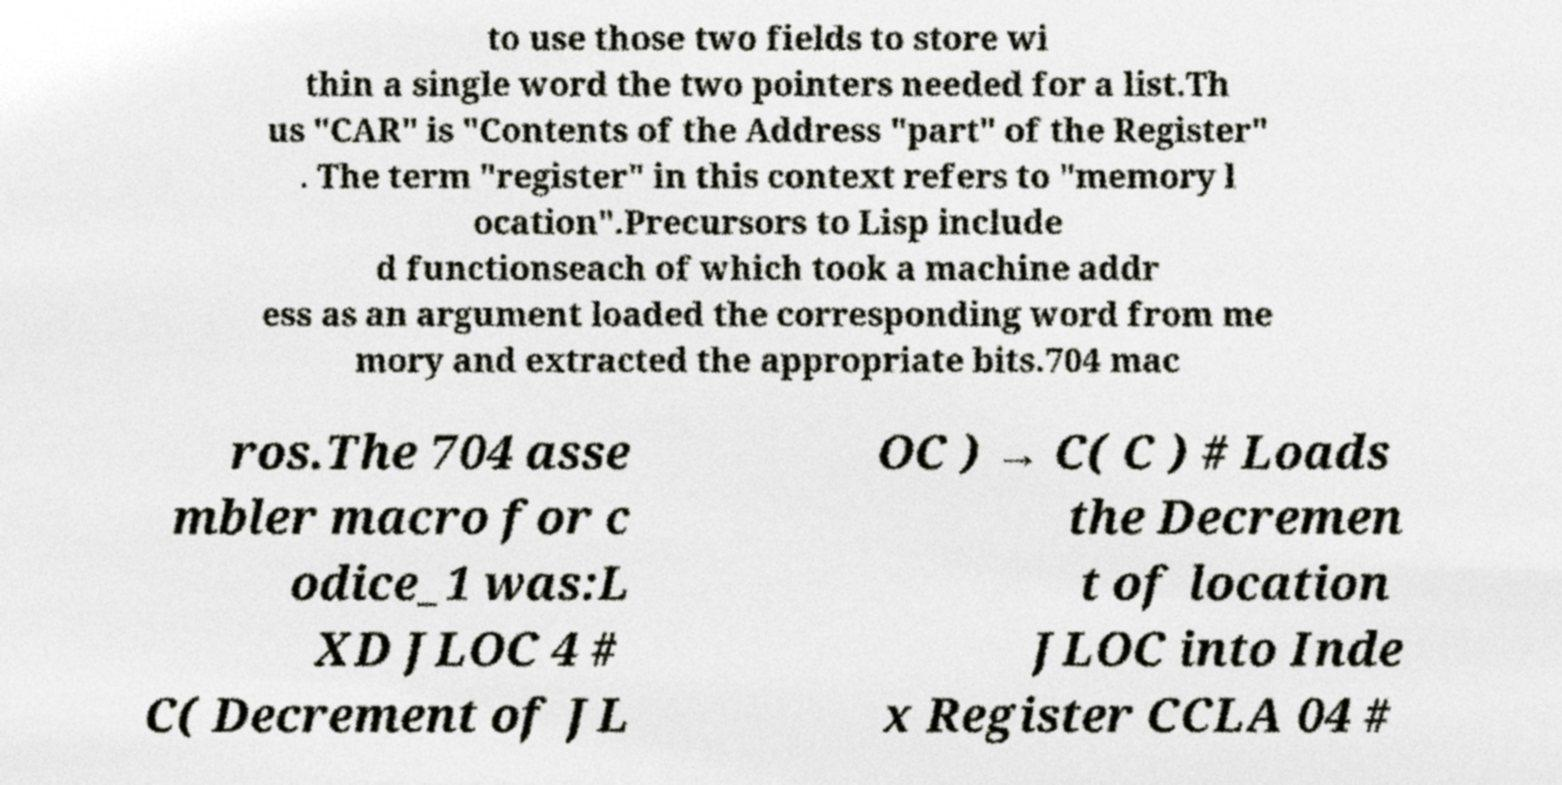What messages or text are displayed in this image? I need them in a readable, typed format. to use those two fields to store wi thin a single word the two pointers needed for a list.Th us "CAR" is "Contents of the Address "part" of the Register" . The term "register" in this context refers to "memory l ocation".Precursors to Lisp include d functionseach of which took a machine addr ess as an argument loaded the corresponding word from me mory and extracted the appropriate bits.704 mac ros.The 704 asse mbler macro for c odice_1 was:L XD JLOC 4 # C( Decrement of JL OC ) → C( C ) # Loads the Decremen t of location JLOC into Inde x Register CCLA 04 # 